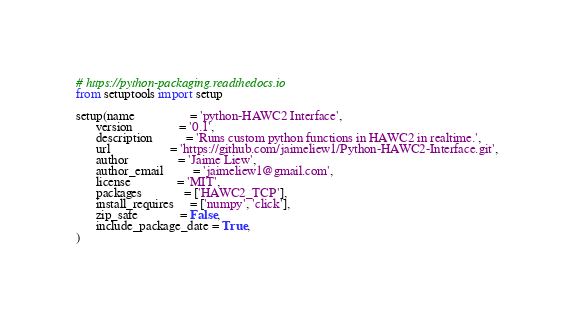Convert code to text. <code><loc_0><loc_0><loc_500><loc_500><_Python_># https://python-packaging.readthedocs.io
from setuptools import setup

setup(name                 = 'python-HAWC2 Interface',
      version              = '0.1',
      description          = 'Runs custom python functions in HAWC2 in realtime.',
      url                  = 'https://github.com/jaimeliew1/Python-HAWC2-Interface.git',
      author               = 'Jaime Liew',
      author_email         = 'jaimeliew1@gmail.com',
      license              = 'MIT',
      packages             = ['HAWC2_TCP'],
      install_requires     = ['numpy', 'click'],
      zip_safe             = False,
      include_package_date = True,
)
</code> 